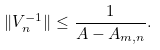Convert formula to latex. <formula><loc_0><loc_0><loc_500><loc_500>\| V _ { n } ^ { - 1 } \| \leq \frac { 1 } { A - A _ { m , n } } .</formula> 